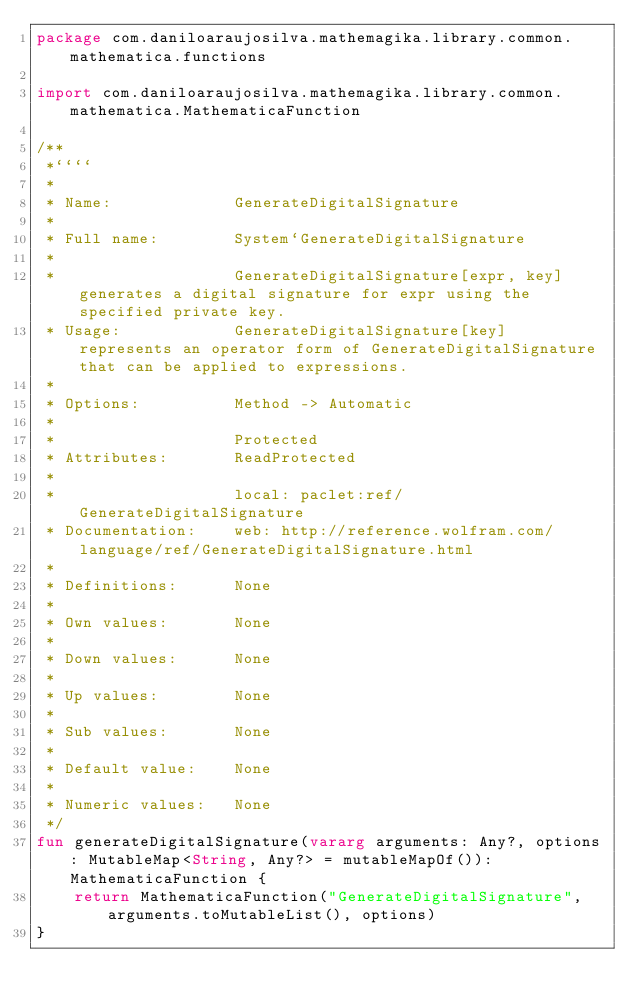Convert code to text. <code><loc_0><loc_0><loc_500><loc_500><_Kotlin_>package com.daniloaraujosilva.mathemagika.library.common.mathematica.functions

import com.daniloaraujosilva.mathemagika.library.common.mathematica.MathematicaFunction

/**
 *````
 *
 * Name:             GenerateDigitalSignature
 *
 * Full name:        System`GenerateDigitalSignature
 *
 *                   GenerateDigitalSignature[expr, key] generates a digital signature for expr using the specified private key.
 * Usage:            GenerateDigitalSignature[key] represents an operator form of GenerateDigitalSignature that can be applied to expressions.
 *
 * Options:          Method -> Automatic
 *
 *                   Protected
 * Attributes:       ReadProtected
 *
 *                   local: paclet:ref/GenerateDigitalSignature
 * Documentation:    web: http://reference.wolfram.com/language/ref/GenerateDigitalSignature.html
 *
 * Definitions:      None
 *
 * Own values:       None
 *
 * Down values:      None
 *
 * Up values:        None
 *
 * Sub values:       None
 *
 * Default value:    None
 *
 * Numeric values:   None
 */
fun generateDigitalSignature(vararg arguments: Any?, options: MutableMap<String, Any?> = mutableMapOf()): MathematicaFunction {
	return MathematicaFunction("GenerateDigitalSignature", arguments.toMutableList(), options)
}
</code> 